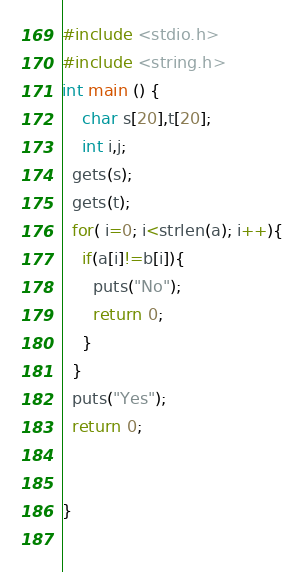Convert code to text. <code><loc_0><loc_0><loc_500><loc_500><_C_>#include <stdio.h>
#include <string.h>
int main () {
	char s[20],t[20];
  	int i,j;
  gets(s);
  gets(t);
  for( i=0; i<strlen(a); i++){
    if(a[i]!=b[i]){
      puts("No");
      return 0;
    }
  }
  puts("Yes");
  return 0;

 
}
  
</code> 